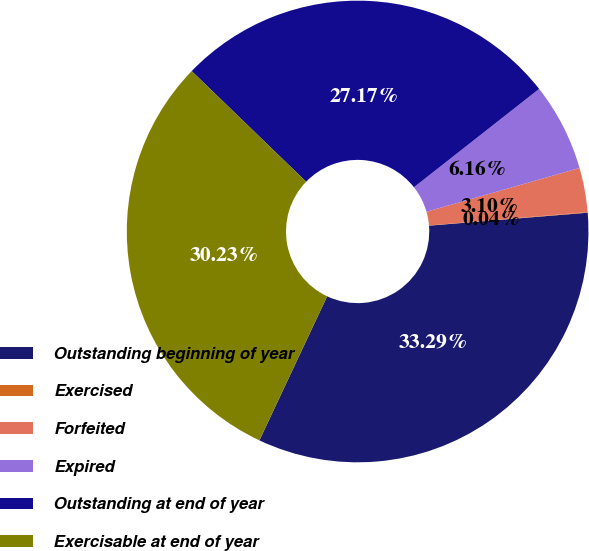Convert chart to OTSL. <chart><loc_0><loc_0><loc_500><loc_500><pie_chart><fcel>Outstanding beginning of year<fcel>Exercised<fcel>Forfeited<fcel>Expired<fcel>Outstanding at end of year<fcel>Exercisable at end of year<nl><fcel>33.29%<fcel>0.04%<fcel>3.1%<fcel>6.16%<fcel>27.17%<fcel>30.23%<nl></chart> 